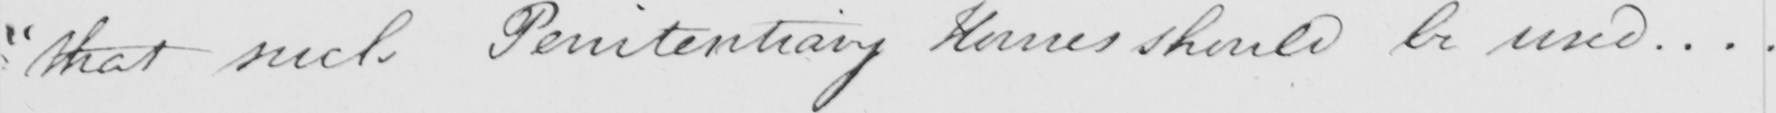What text is written in this handwritten line? " that such Penitentiary Houses should be used .  .  .  . 